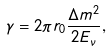<formula> <loc_0><loc_0><loc_500><loc_500>\gamma = 2 \pi r _ { 0 } \frac { \Delta m ^ { 2 } } { 2 E _ { \nu } } ,</formula> 